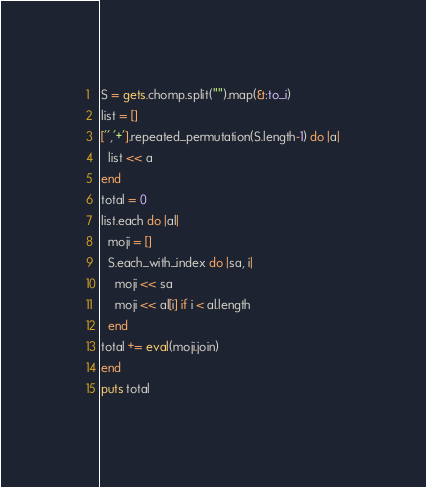Convert code to text. <code><loc_0><loc_0><loc_500><loc_500><_Ruby_>S = gets.chomp.split("").map(&:to_i)
list = []
['','+'].repeated_permutation(S.length-1) do |a|
  list << a
end
total = 0
list.each do |al|
  moji = []
  S.each_with_index do |sa, i|
    moji << sa
    moji << al[i] if i < al.length
  end
total += eval(moji.join)
end
puts total
</code> 